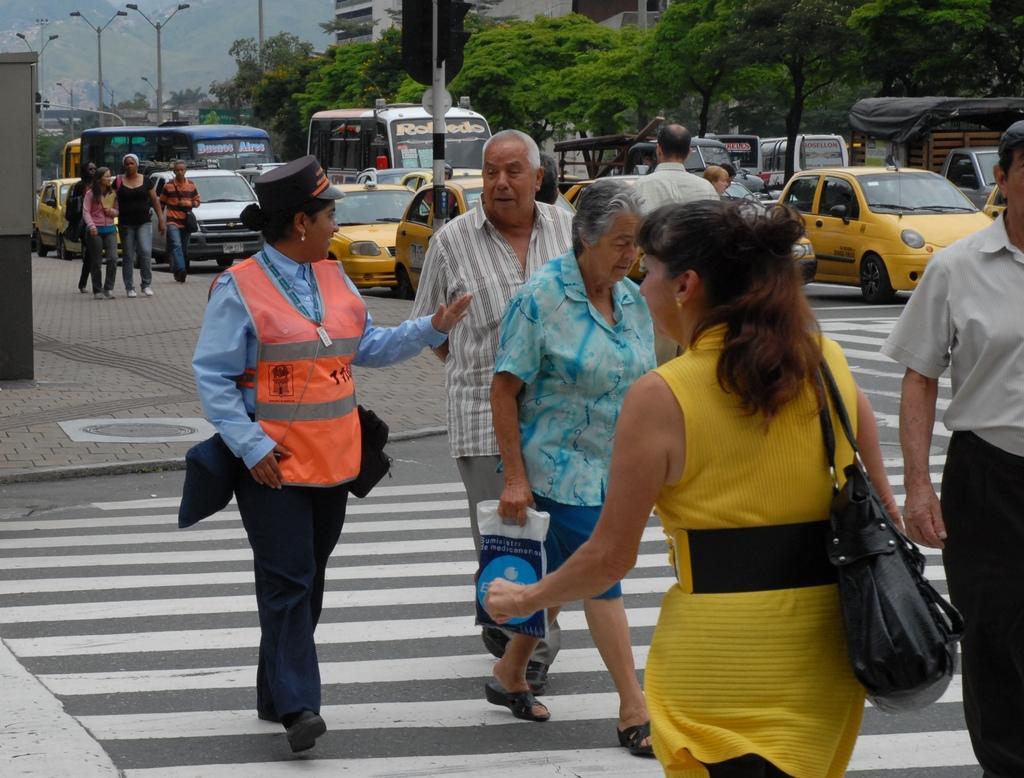Please provide a concise description of this image. In this image we can see many vehicles. There are many trees in the image. There are few street lights in the image. We can see few buildings in the image. There is an object at the left side of the image. We can see few people walking on the road and few people carrying some objects in their hands. We can see few people walking on the footpath at the left side of the image. 